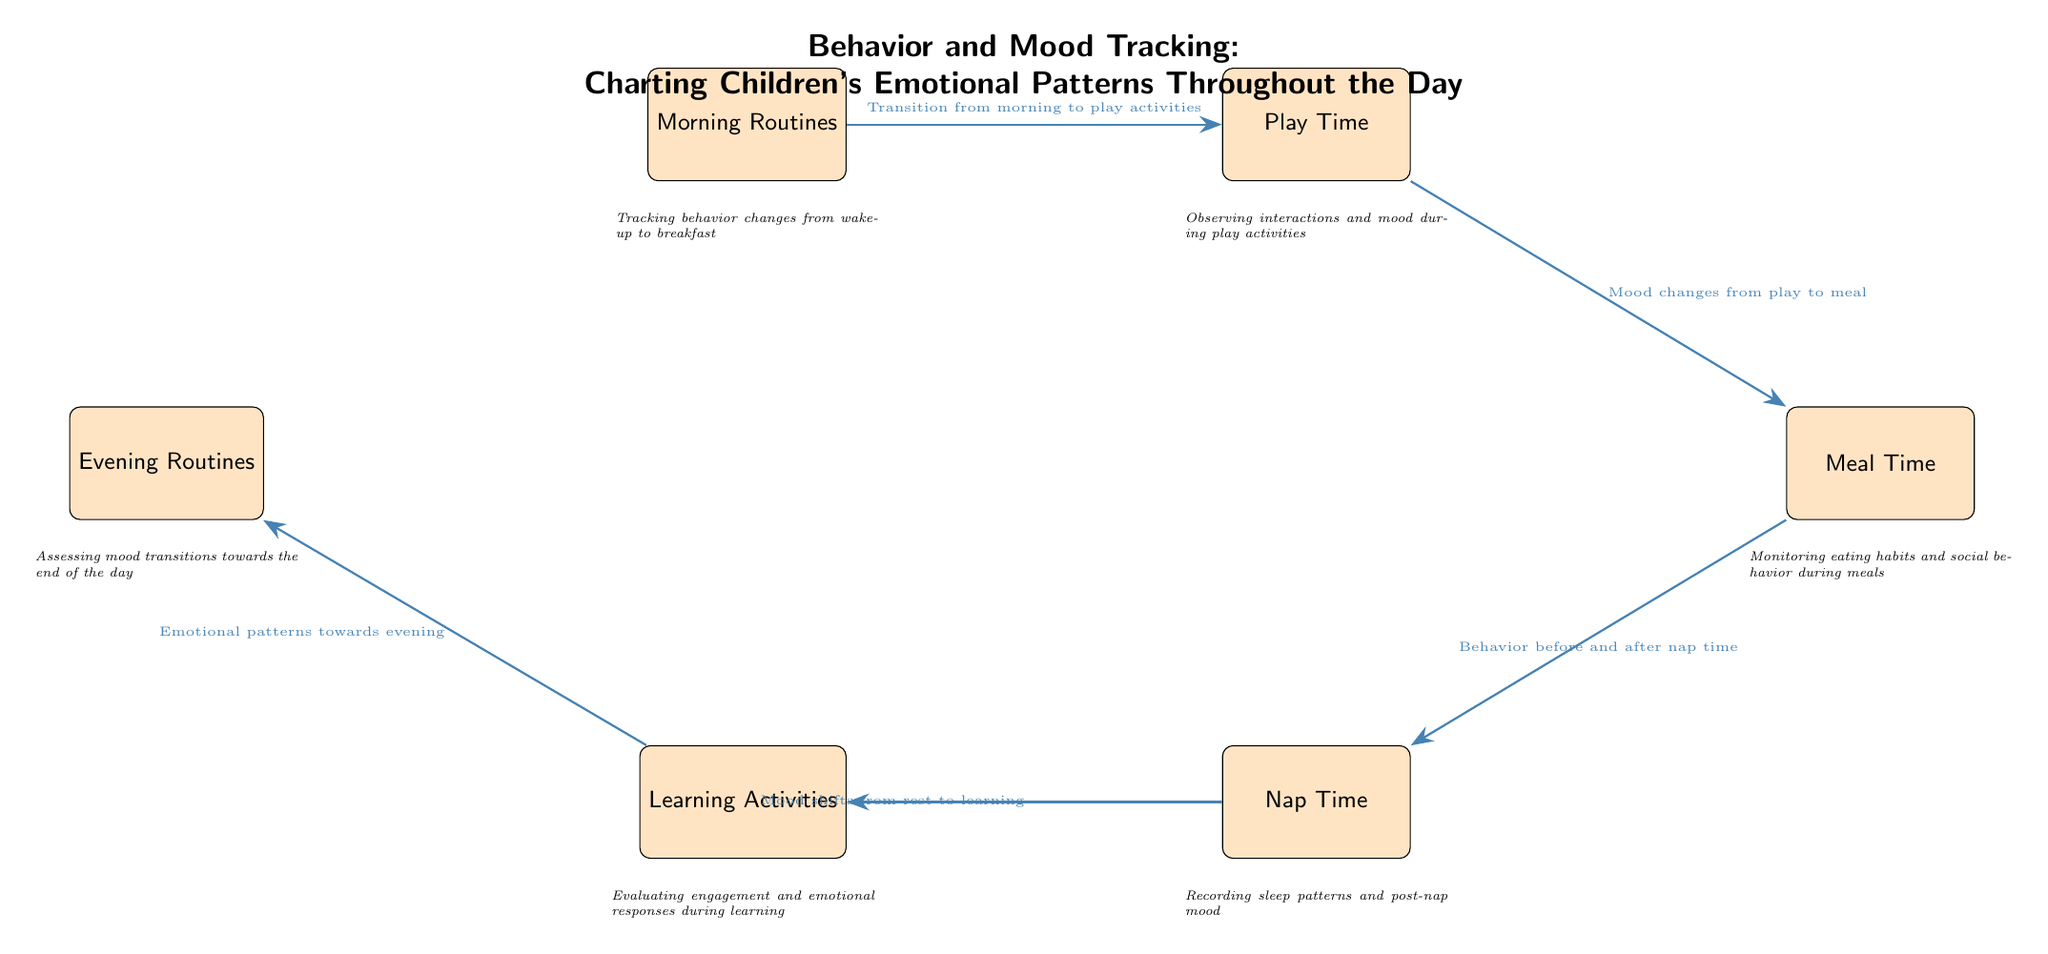What is the first node in the diagram? The first node listed in the diagram is "Morning Routines." This is the starting point for tracking children's behavior and mood throughout the day.
Answer: Morning Routines How many nodes are in the diagram? By counting all the distinct colored rectangles, there are six nodes present in the diagram. Each represents a different time or activity of the day.
Answer: Six What is the last node in the flow of the diagram? The last node in the flow is "Evening Routines." This represents the final part of the day where mood assessments are made.
Answer: Evening Routines What does the arrow from "Play Time" to "Meal Time" indicate? The arrow indicates a transition in behavior and mood, specifically showing how moods change from play activities to meal time, highlighting the response to different activities.
Answer: Mood changes from play to meal Which node follows "Nap Time"? The node that immediately follows "Nap Time" is "Learning Activities." It captures the transition from resting to engaging in learning tasks post-nap.
Answer: Learning Activities How are the descriptions arranged in the diagram? The descriptions are located directly below each respective node, providing additional context about what is being tracked during that part of the day.
Answer: Below each node What are the key emotional patterns monitored during "Learning Activities"? During "Learning Activities," emotional responses and engagement levels are evaluated, which helps understand how children react to educational tasks.
Answer: Engagement and emotional responses What does the arrow from "Nap Time" suggest about children's behavior? The arrow indicates that there is a connection between "Nap Time" and "Learning Activities," specifically focusing on mood shifts following rest, suggesting that nap quality influences learning readiness.
Answer: Mood shifts from rest to learning Which activity assesses mood transitions towards the end of the day? The activity that assesses mood transitions towards the end of the day is "Evening Routines," which focuses on evaluating emotional changes as the day concludes.
Answer: Evening Routines 